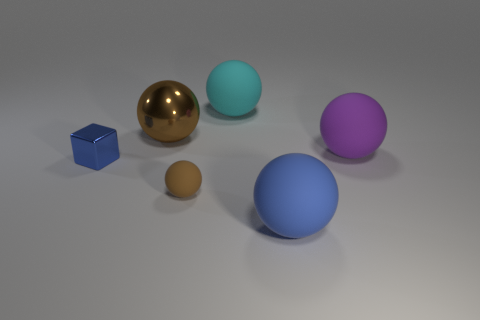There is a matte sphere that is the same color as the large metal object; what is its size?
Provide a short and direct response. Small. There is another object that is the same color as the small rubber object; what is its shape?
Make the answer very short. Sphere. There is a shiny object that is to the left of the large brown shiny ball; what size is it?
Offer a very short reply. Small. What number of large things are either brown balls or purple matte things?
Give a very brief answer. 2. There is another small matte object that is the same shape as the blue matte thing; what color is it?
Your response must be concise. Brown. Does the cyan matte thing have the same size as the blue shiny block?
Your answer should be compact. No. What number of things are either cyan matte spheres or balls that are to the right of the large metallic sphere?
Make the answer very short. 4. What is the color of the big matte sphere that is on the left side of the blue thing that is to the right of the large cyan rubber sphere?
Give a very brief answer. Cyan. Does the metal thing that is in front of the big shiny thing have the same color as the large metallic ball?
Offer a terse response. No. What material is the blue object behind the blue matte ball?
Your response must be concise. Metal. 